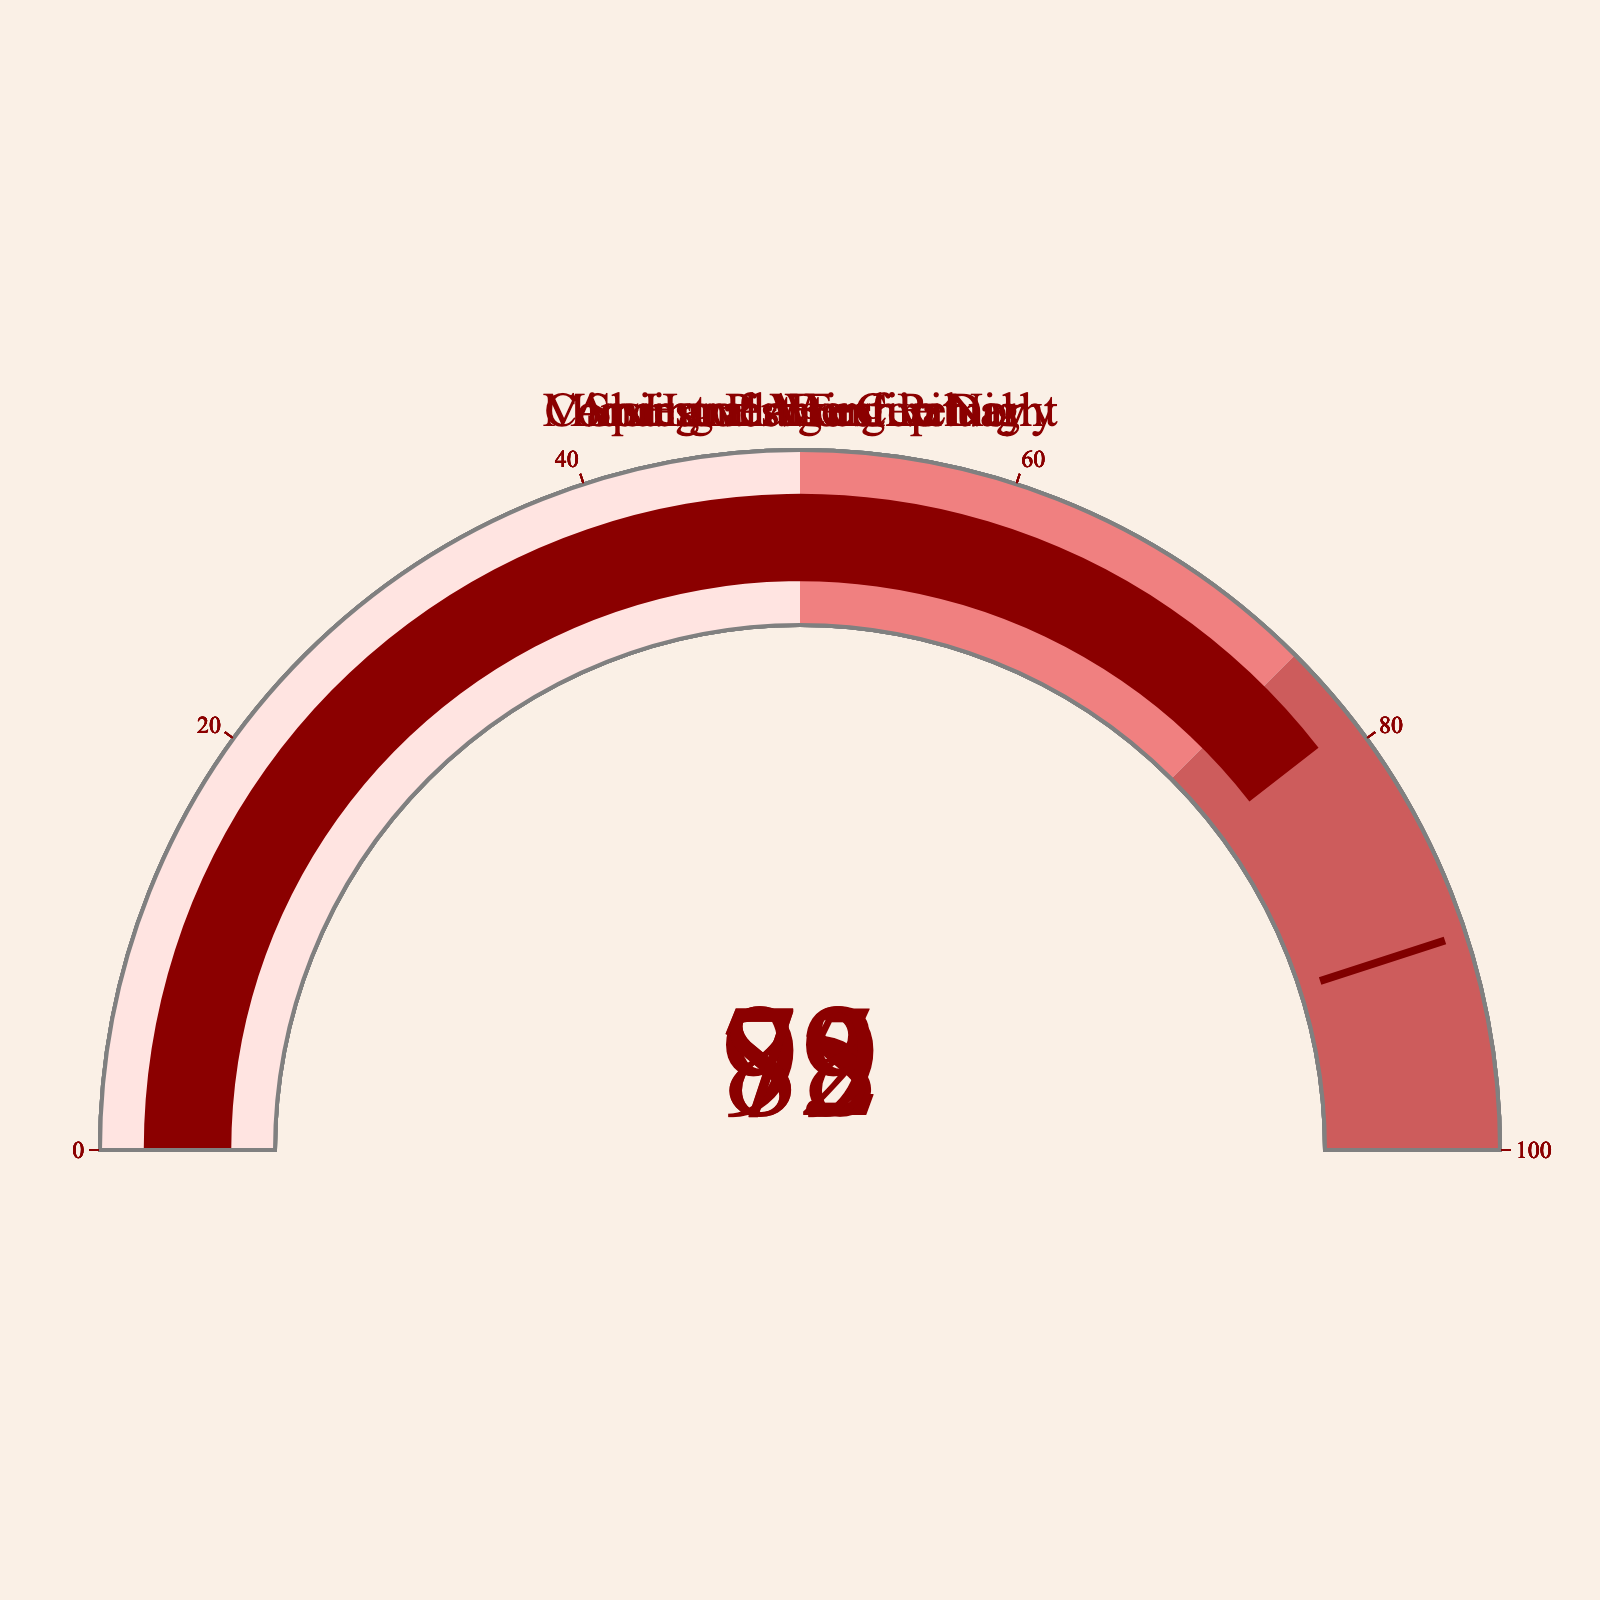What's the attendance rate for the Harvest Festival? To determine the attendance rate for the Harvest Festival, you need to locate the specific gauge labeled "Harvest Festival" in the figure. The gauge shows the percentage value, which represents the attendance rate for that festival.
Answer: 92% How many festivals have an attendance rate above 80%? Examine each gauge in the figure to identify those with attendance rates exceeding 80%. Count these gauges to determine the total number of festivals with attendance rates above 80%.
Answer: 3 Which festival has the lowest attendance rate? Compare the percentage values on all the gauges displayed in the figure. Identify the gauge with the smallest percentage value, which indicates the festival with the lowest attendance rate.
Answer: Coming of Age Ceremony What's the difference in attendance rates between Ancestral Worship Day and Midsummer Bonfire Night? Locate the gauges for Ancestral Worship Day and Midsummer Bonfire Night. Note their attendance rates (88% and 79%, respectively). Subtract the lower value from the higher one to find the difference. 88% - 79% = 9%
Answer: 9% How many festivals have attendance rates between 75% and 90%? Identify the gauges with attendance rates falling within the range of 75% to 90%. Count these gauges to determine the number of festivals within this attendance range.
Answer: 3 Is the attendance rate for the Harvest Festival greater than the average attendance rate of all the festivals? First, calculate the average attendance rate of all the festivals by summing their attendance rates and dividing by the number of festivals (92 + 88 + 75 + 83 + 79) / 5 = 417 / 5 = 83.4%. Then, compare this average with the Harvest Festival's attendance rate of 92%. Since 92% > 83.4%, the attendance rate for the Harvest Festival is indeed greater than the average.
Answer: Yes Which festival's attendance rate is closest to the value of its threshold indicator? Identify each festival's attendance rate and its corresponding threshold indicator value (assuming default threshold is 90%). Find the festival with the attendance rate nearest to the threshold value. The attendance rates are: 92, 88, 75, 83, 79. The festival closest to 90% is Ancestral Worship Day at 88%.
Answer: Ancestral Worship Day 